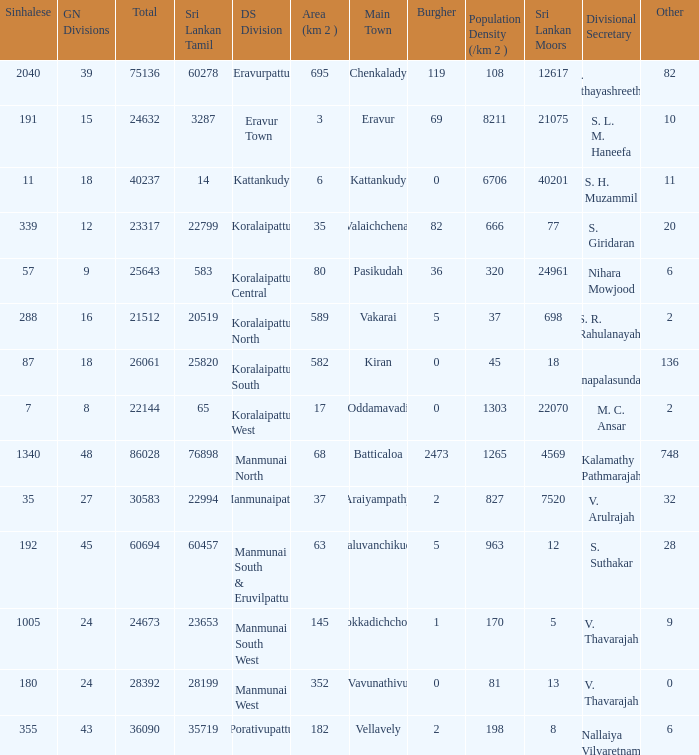Kaluvanchikudy is the main town in what DS division? Manmunai South & Eruvilpattu. 